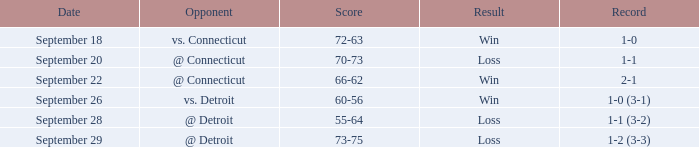Who is the adversary with a score of 72-63? Vs. connecticut. 